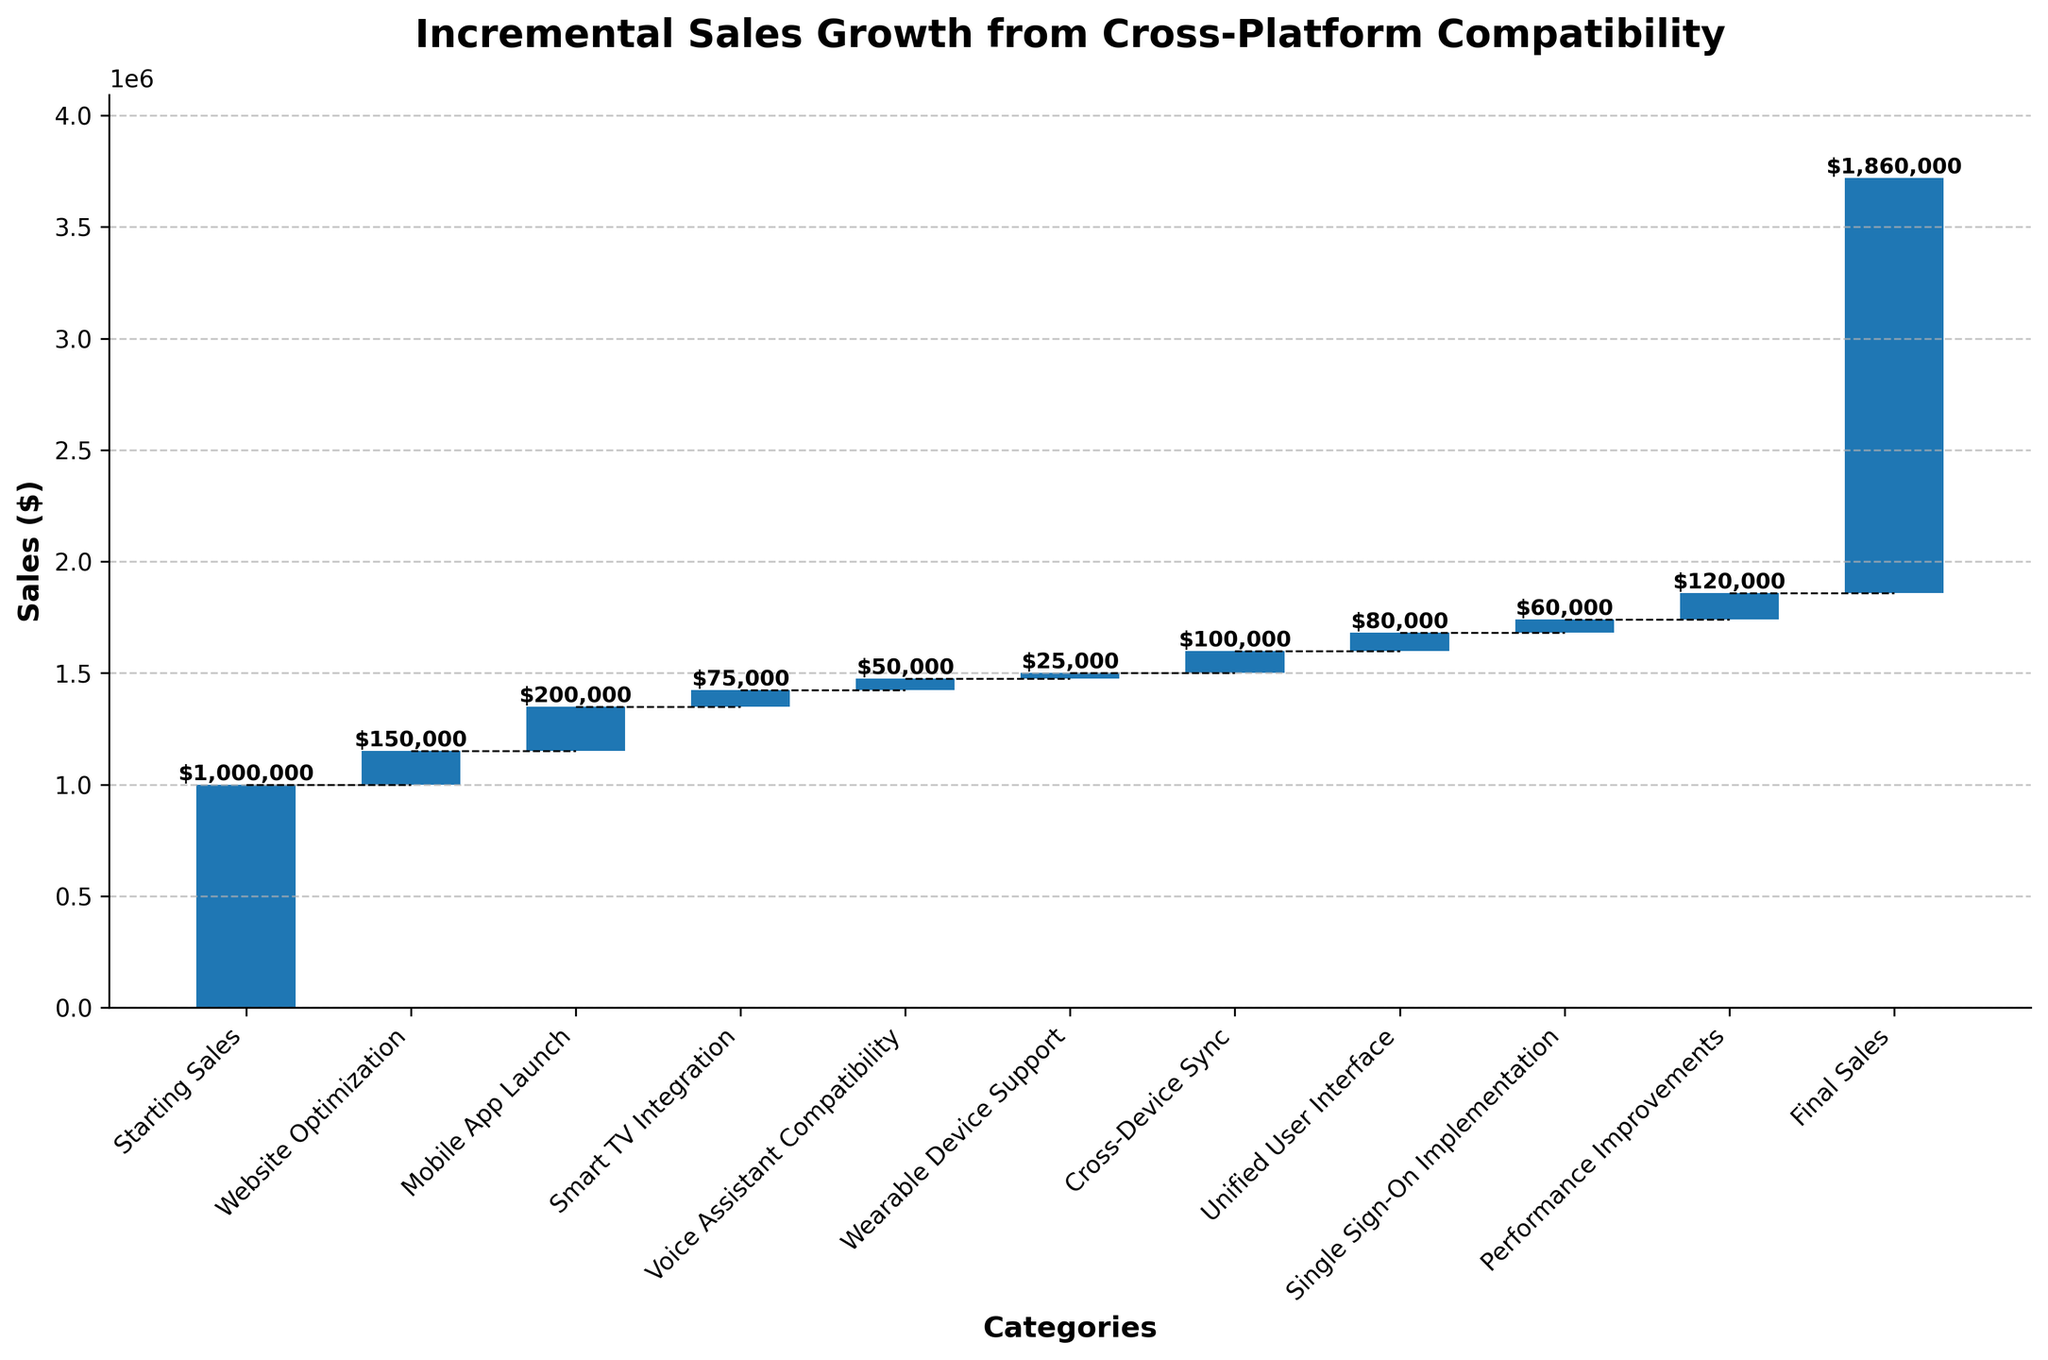What is the title of the figure? Look at the top of the figure where the title is usually placed to identify it.
Answer: Incremental Sales Growth from Cross-Platform Compatibility What is the final sales value displayed in the figure? Look at the last bar in the waterfall chart and read the label or value on top of that bar.
Answer: $1,860,000 Which category contributed the highest incremental sales growth? Compare the heights of the bars and identify the one with the largest value increment.
Answer: Mobile App Launch How much did the Cross-Device Sync category contribute to incremental sales? Locate the bar labeled "Cross-Device Sync" and read the value on the label of the bar.
Answer: $100,000 What is the cumulative sales value after the Mobile App Launch? Find the value at the top of the Mobile App Launch bar and add it to the value of preceding cumulative sales. The cumulative value after Mobile App Launch is $1,350,000
Answer: $1,350,000 How does the contribution of Smart TV Integration compare to Performance Improvements? Compare the heights of the bars labeled "Smart TV Integration" and "Performance Improvements".
Answer: Smart TV Integration is smaller What is the total sales growth attributed to all categories except the Starting Sales? Sum the values contributed by all categories except the "Starting Sales". The total sum is $150,000 + $200,000 + $75,000 + $50,000 + $25,000 + $100,000 + $80,000 + $60,000 + $120,000 = $860,000
Answer: $860,000 Which category had the smallest incremental sales contribution, and what is its value? Identify the shortest bar which also has the smallest value label.
Answer: Wearable Device Support; $25,000 What is the percentage increase in sales from the Starting Sales to Final Sales? Calculate the percentage increase using the formula \(\frac{(Final Sales - Starting Sales)}{Starting Sales} \times 100\%. So, the increase is \(\frac{(1,860,000 - 1,000,000)}{1,000,000} \times 100\% = 86\%\)
Answer: 86% How many categories contribute to the incremental sales growth? Count the number of bars excluding the Starting Sales and Final Sales bars in the figure.
Answer: 9 